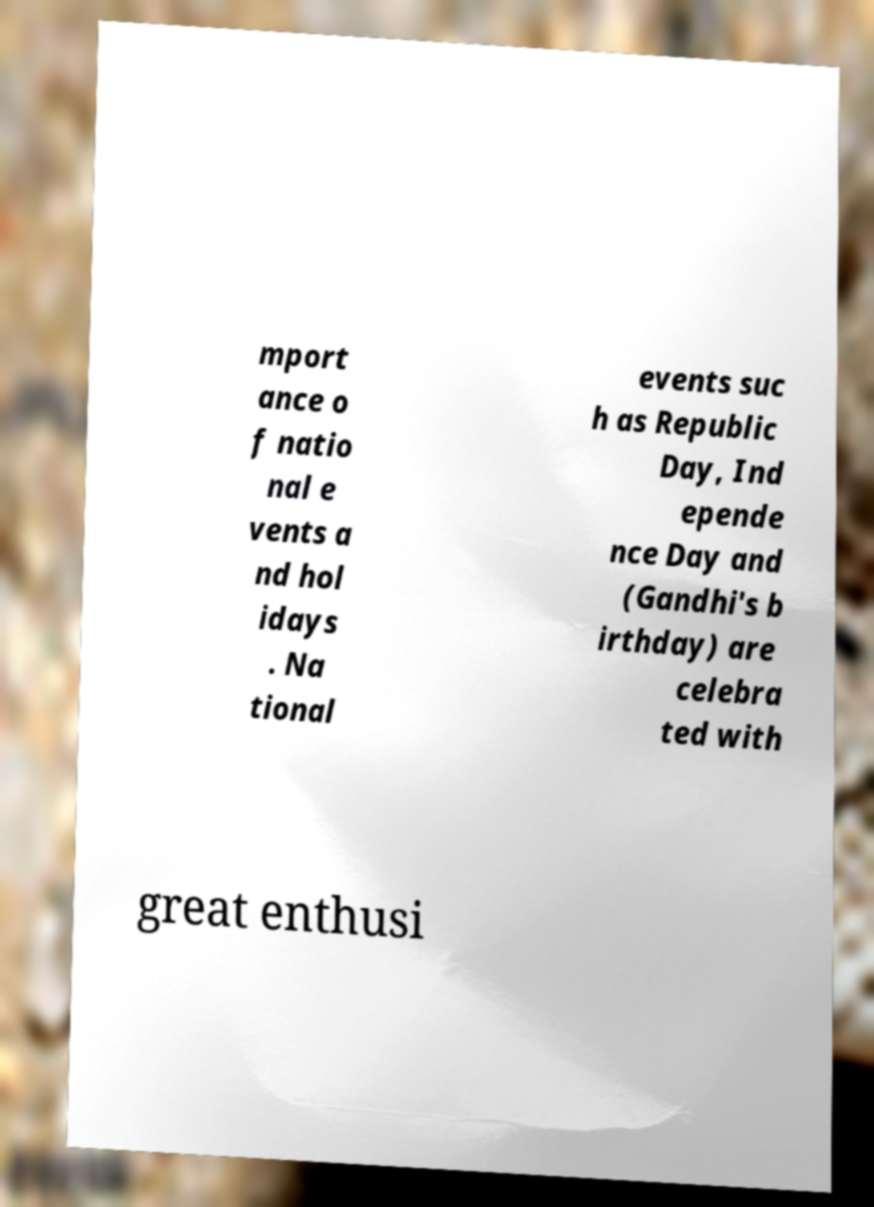Could you extract and type out the text from this image? mport ance o f natio nal e vents a nd hol idays . Na tional events suc h as Republic Day, Ind epende nce Day and (Gandhi's b irthday) are celebra ted with great enthusi 